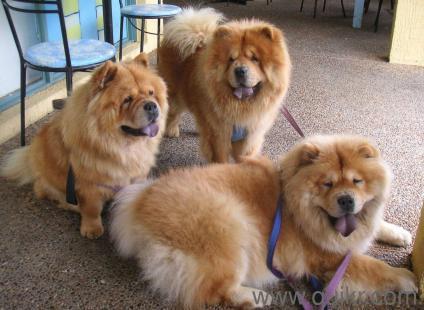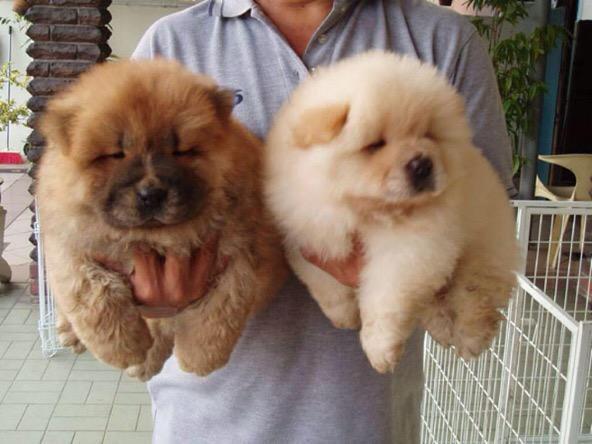The first image is the image on the left, the second image is the image on the right. Given the left and right images, does the statement "There are no less than two dogs in each image." hold true? Answer yes or no. Yes. The first image is the image on the left, the second image is the image on the right. Analyze the images presented: Is the assertion "There are only two dogs." valid? Answer yes or no. No. 